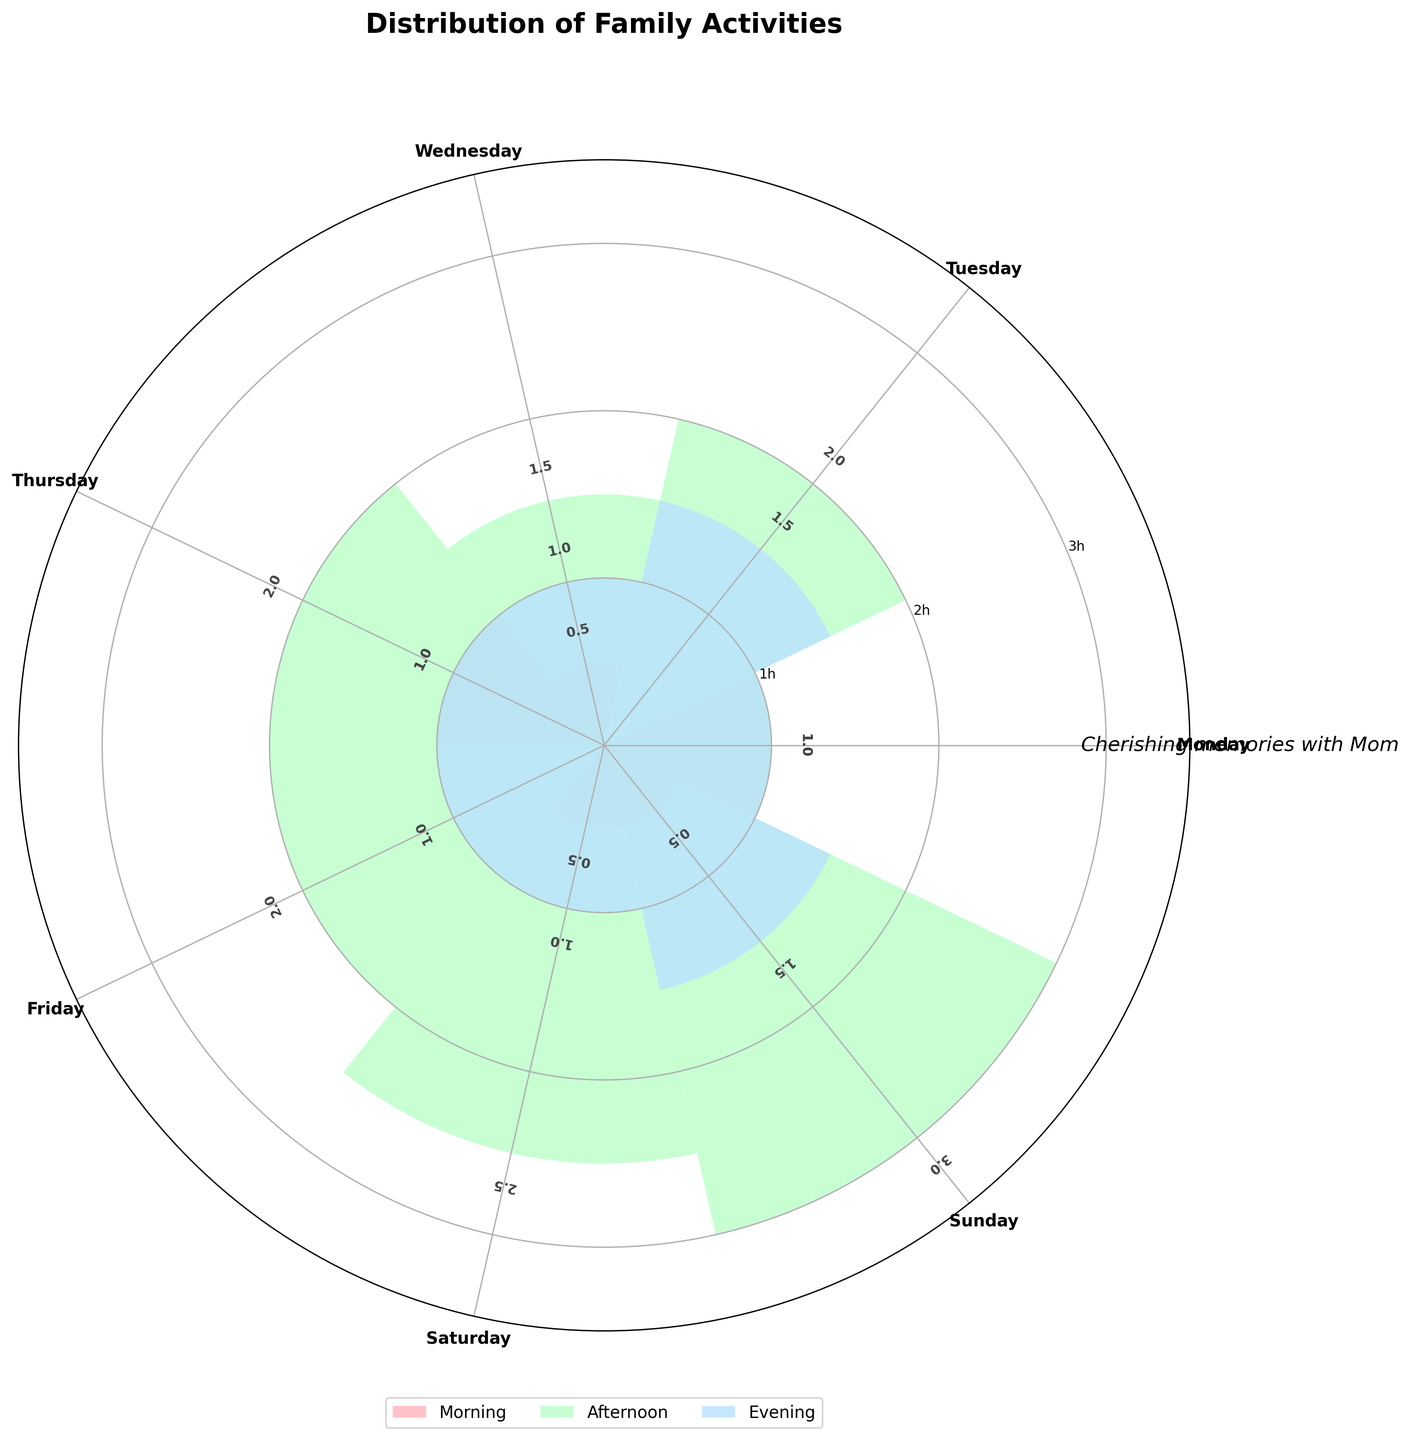What is the title of the plot? The title is often prominently displayed to provide a clear description of the figure. In this plot, the title can be found at the top center, indicating what the chart is about.
Answer: Distribution of Family Activities What are the days of the week labeled on the plot? The labels for the days of the week are arranged around the outer edge of the polar plot and can be easily identified as you move around the circle. They provide a reference for interpreting the radial bars for each day.
Answer: Monday, Tuesday, Wednesday, Thursday, Friday, Saturday, Sunday Which time of day has the highest activity on Tuesday? By inspecting the bars representing Tuesday and comparing their heights, you can discern which time of day had the longest duration of activity.
Answer: Afternoon How many hours were spent on family dinner over the entire week? To find this, look at the "Family dinner" bars across all the days of the week and sum their durations: Monday (1.0), Wednesday (1.0), and Saturday (1.0).
Answer: 3.0 hours On which day and time was the longest single activity duration, and what was the activity? Examine the radial bars for each activity across the week and identify the bar that extends the furthest from the center, indicating the longest duration.
Answer: Sunday, Afternoon, Visiting relatives How does the distribution of morning activities compare to evening activities throughout the week? Compare the cumulative heights of the morning bars to the evening bars. You’ll need to sum their respective durations: Morning: Monday (1.0), Wednesday (0.5), Thursday (1.0), Saturday (0.5), Sunday (0.5); Evening: Monday (1.0), Tuesday (1.5), Wednesday (1.0), Thursday (1.0), Friday (1.0), Saturday (1.0), Sunday (1.5).
Answer: More activities in the evening than in the morning Which day had the fewest activities overall, and what can you deduce from this? Sum the duration of activities for each day and compare them. For Monday: 0.5+0.5+1.0+1.0 = 3.0 hours. Repeat for other days, then compare the totals.
Answer: Monday What special message or touch is added to this plot? Some plots include a personal note or message. Here, it's added as text somewhere in the plot area, typically on the top.
Answer: Cherishing memories with Mom On which day and time was storytelling done? Look for the "Storytelling" bar among the activities listed for each day and identify its corresponding day and time.
Answer: Friday, Evening Which time of day has the most diverse range of activities, and how do you know? Identify the time of day with the highest variety of different activities (number of unique activities) by examining the labels and colors of the bars.
Answer: Afternoon How many unique activities were done on Thursday? Count the different activity labels corresponding to Thursday on the plot: Morning (Walking), Afternoon (Baking cookies), Evening (Board games).
Answer: 3 